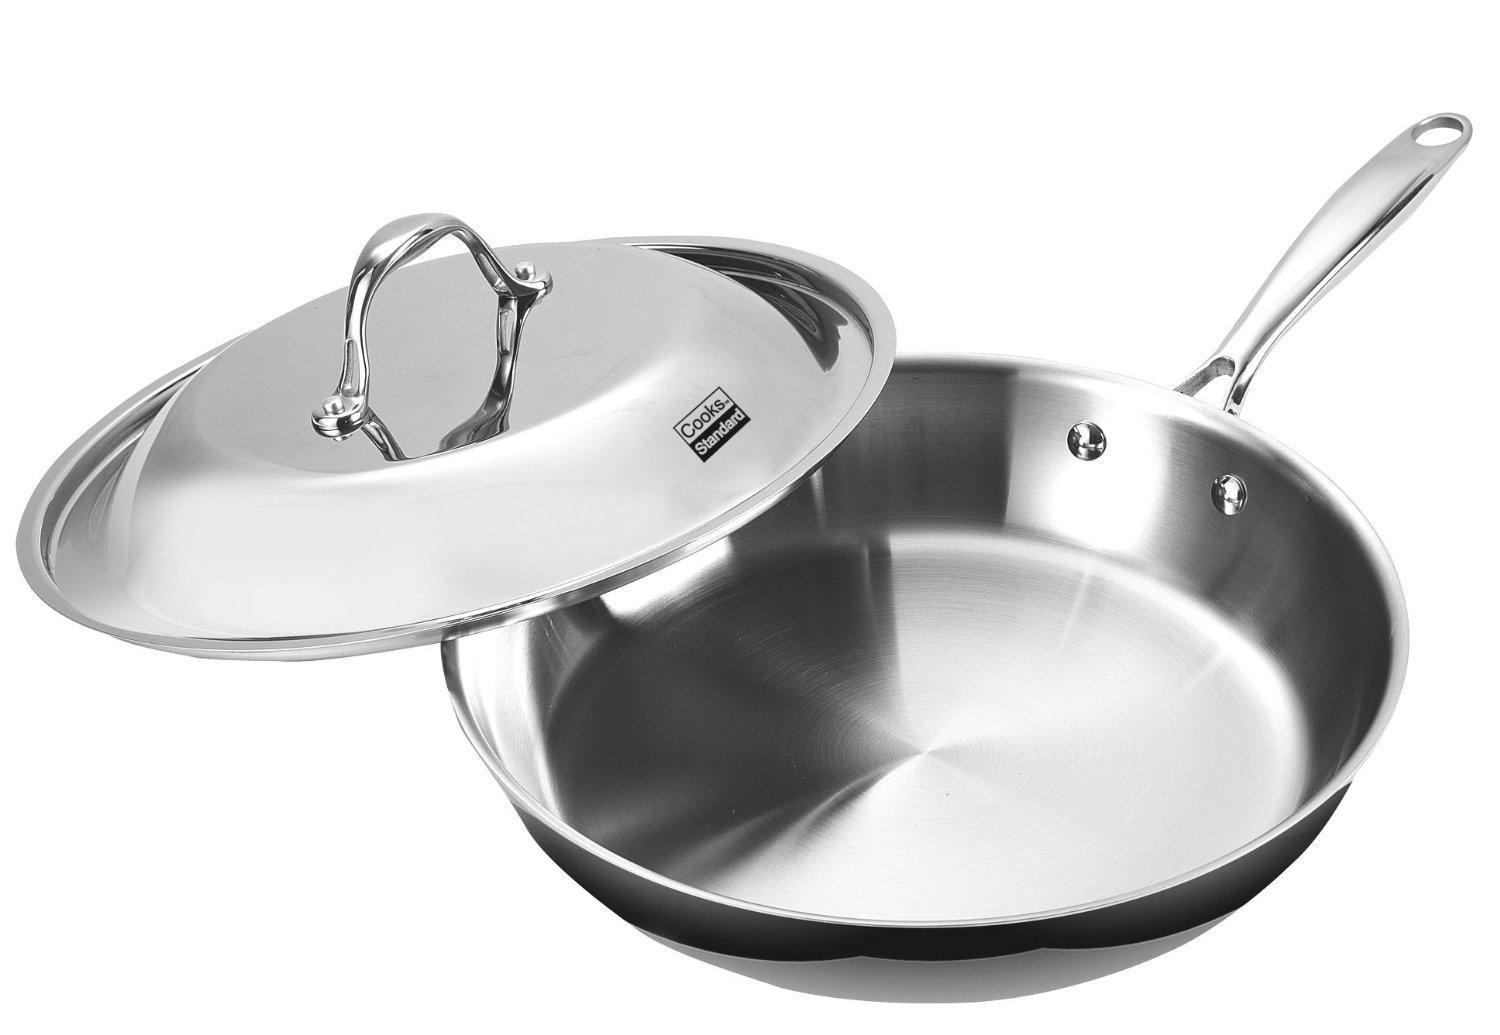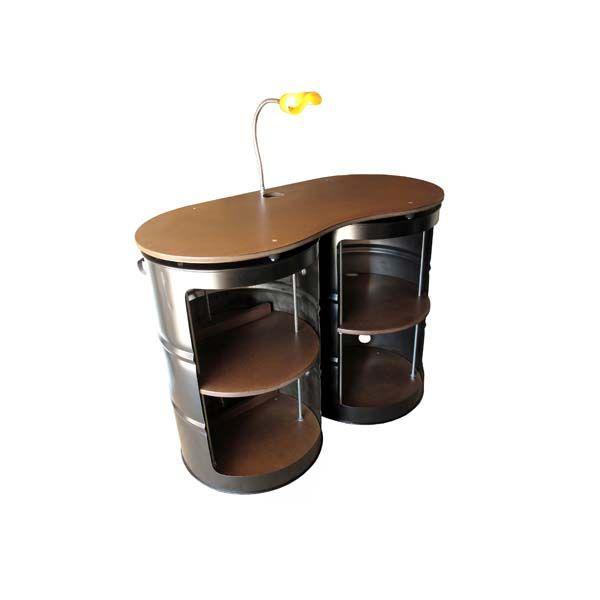The first image is the image on the left, the second image is the image on the right. Evaluate the accuracy of this statement regarding the images: "In at least one image there is a black metal barrel with a lid on.". Is it true? Answer yes or no. No. 